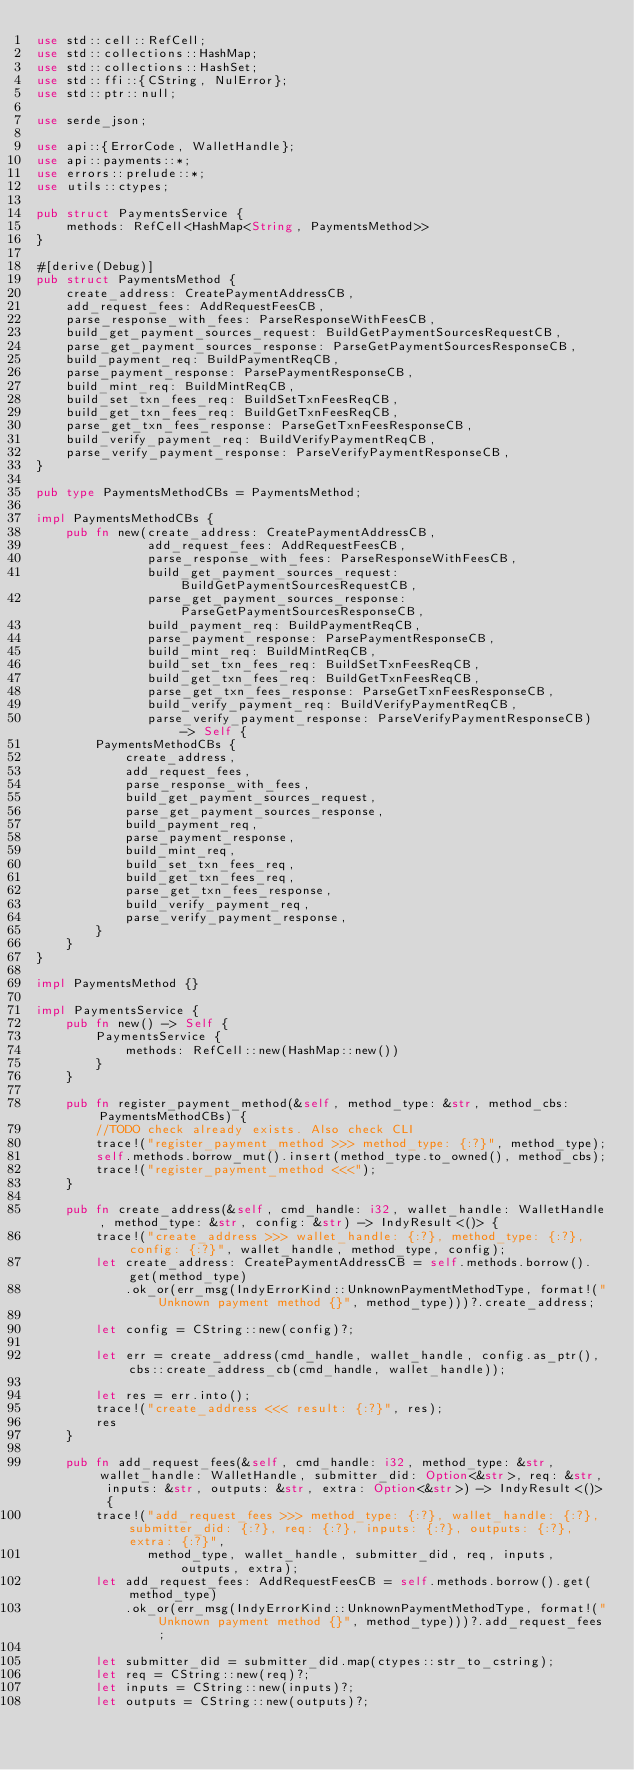Convert code to text. <code><loc_0><loc_0><loc_500><loc_500><_Rust_>use std::cell::RefCell;
use std::collections::HashMap;
use std::collections::HashSet;
use std::ffi::{CString, NulError};
use std::ptr::null;

use serde_json;

use api::{ErrorCode, WalletHandle};
use api::payments::*;
use errors::prelude::*;
use utils::ctypes;

pub struct PaymentsService {
    methods: RefCell<HashMap<String, PaymentsMethod>>
}

#[derive(Debug)]
pub struct PaymentsMethod {
    create_address: CreatePaymentAddressCB,
    add_request_fees: AddRequestFeesCB,
    parse_response_with_fees: ParseResponseWithFeesCB,
    build_get_payment_sources_request: BuildGetPaymentSourcesRequestCB,
    parse_get_payment_sources_response: ParseGetPaymentSourcesResponseCB,
    build_payment_req: BuildPaymentReqCB,
    parse_payment_response: ParsePaymentResponseCB,
    build_mint_req: BuildMintReqCB,
    build_set_txn_fees_req: BuildSetTxnFeesReqCB,
    build_get_txn_fees_req: BuildGetTxnFeesReqCB,
    parse_get_txn_fees_response: ParseGetTxnFeesResponseCB,
    build_verify_payment_req: BuildVerifyPaymentReqCB,
    parse_verify_payment_response: ParseVerifyPaymentResponseCB,
}

pub type PaymentsMethodCBs = PaymentsMethod;

impl PaymentsMethodCBs {
    pub fn new(create_address: CreatePaymentAddressCB,
               add_request_fees: AddRequestFeesCB,
               parse_response_with_fees: ParseResponseWithFeesCB,
               build_get_payment_sources_request: BuildGetPaymentSourcesRequestCB,
               parse_get_payment_sources_response: ParseGetPaymentSourcesResponseCB,
               build_payment_req: BuildPaymentReqCB,
               parse_payment_response: ParsePaymentResponseCB,
               build_mint_req: BuildMintReqCB,
               build_set_txn_fees_req: BuildSetTxnFeesReqCB,
               build_get_txn_fees_req: BuildGetTxnFeesReqCB,
               parse_get_txn_fees_response: ParseGetTxnFeesResponseCB,
               build_verify_payment_req: BuildVerifyPaymentReqCB,
               parse_verify_payment_response: ParseVerifyPaymentResponseCB) -> Self {
        PaymentsMethodCBs {
            create_address,
            add_request_fees,
            parse_response_with_fees,
            build_get_payment_sources_request,
            parse_get_payment_sources_response,
            build_payment_req,
            parse_payment_response,
            build_mint_req,
            build_set_txn_fees_req,
            build_get_txn_fees_req,
            parse_get_txn_fees_response,
            build_verify_payment_req,
            parse_verify_payment_response,
        }
    }
}

impl PaymentsMethod {}

impl PaymentsService {
    pub fn new() -> Self {
        PaymentsService {
            methods: RefCell::new(HashMap::new())
        }
    }

    pub fn register_payment_method(&self, method_type: &str, method_cbs: PaymentsMethodCBs) {
        //TODO check already exists. Also check CLI
        trace!("register_payment_method >>> method_type: {:?}", method_type);
        self.methods.borrow_mut().insert(method_type.to_owned(), method_cbs);
        trace!("register_payment_method <<<");
    }

    pub fn create_address(&self, cmd_handle: i32, wallet_handle: WalletHandle, method_type: &str, config: &str) -> IndyResult<()> {
        trace!("create_address >>> wallet_handle: {:?}, method_type: {:?}, config: {:?}", wallet_handle, method_type, config);
        let create_address: CreatePaymentAddressCB = self.methods.borrow().get(method_type)
            .ok_or(err_msg(IndyErrorKind::UnknownPaymentMethodType, format!("Unknown payment method {}", method_type)))?.create_address;

        let config = CString::new(config)?;

        let err = create_address(cmd_handle, wallet_handle, config.as_ptr(), cbs::create_address_cb(cmd_handle, wallet_handle));

        let res = err.into();
        trace!("create_address <<< result: {:?}", res);
        res
    }

    pub fn add_request_fees(&self, cmd_handle: i32, method_type: &str, wallet_handle: WalletHandle, submitter_did: Option<&str>, req: &str, inputs: &str, outputs: &str, extra: Option<&str>) -> IndyResult<()> {
        trace!("add_request_fees >>> method_type: {:?}, wallet_handle: {:?}, submitter_did: {:?}, req: {:?}, inputs: {:?}, outputs: {:?}, extra: {:?}",
               method_type, wallet_handle, submitter_did, req, inputs, outputs, extra);
        let add_request_fees: AddRequestFeesCB = self.methods.borrow().get(method_type)
            .ok_or(err_msg(IndyErrorKind::UnknownPaymentMethodType, format!("Unknown payment method {}", method_type)))?.add_request_fees;

        let submitter_did = submitter_did.map(ctypes::str_to_cstring);
        let req = CString::new(req)?;
        let inputs = CString::new(inputs)?;
        let outputs = CString::new(outputs)?;</code> 